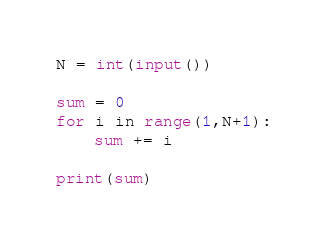<code> <loc_0><loc_0><loc_500><loc_500><_Python_>N = int(input())

sum = 0
for i in range(1,N+1):
    sum += i

print(sum)</code> 